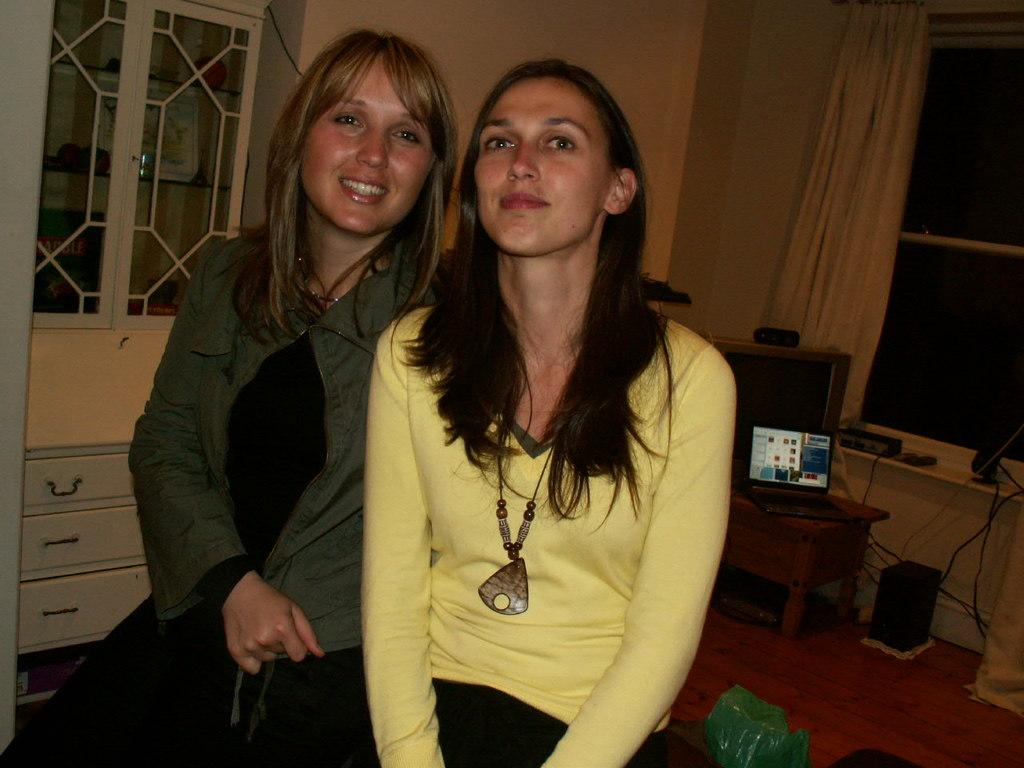How many women are in the image? There are two women in the image. What are the women doing in the image? The women are sitting in the image. What is the facial expression of the women? The women are smiling in the image. What can be seen in the background of the image? In the background of the image, there is a wall, curtains, a frame, wires, speakers, a monitor, a window, and racks. What type of alley can be seen behind the women in the image? There is no alley present in the image. On which side of the women are the racks located in the image? The racks are located in the background of the image, and their specific side cannot be determined from the provided facts. 